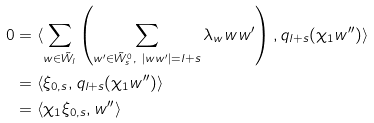Convert formula to latex. <formula><loc_0><loc_0><loc_500><loc_500>0 & = \langle \sum _ { w \in \tilde { W } _ { l } } \left ( \sum _ { w ^ { \prime } \in \tilde { W } _ { s } ^ { 0 } , \ | w w ^ { \prime } | = l + s } \lambda _ { w } w w ^ { \prime } \right ) , q _ { l + s } ( \chi _ { 1 } w ^ { \prime \prime } ) \rangle \\ & = \langle \xi _ { 0 , s } , q _ { l + s } ( \chi _ { 1 } w ^ { \prime \prime } ) \rangle \\ & = \langle \chi _ { 1 } \xi _ { 0 , s } , w ^ { \prime \prime } \rangle</formula> 